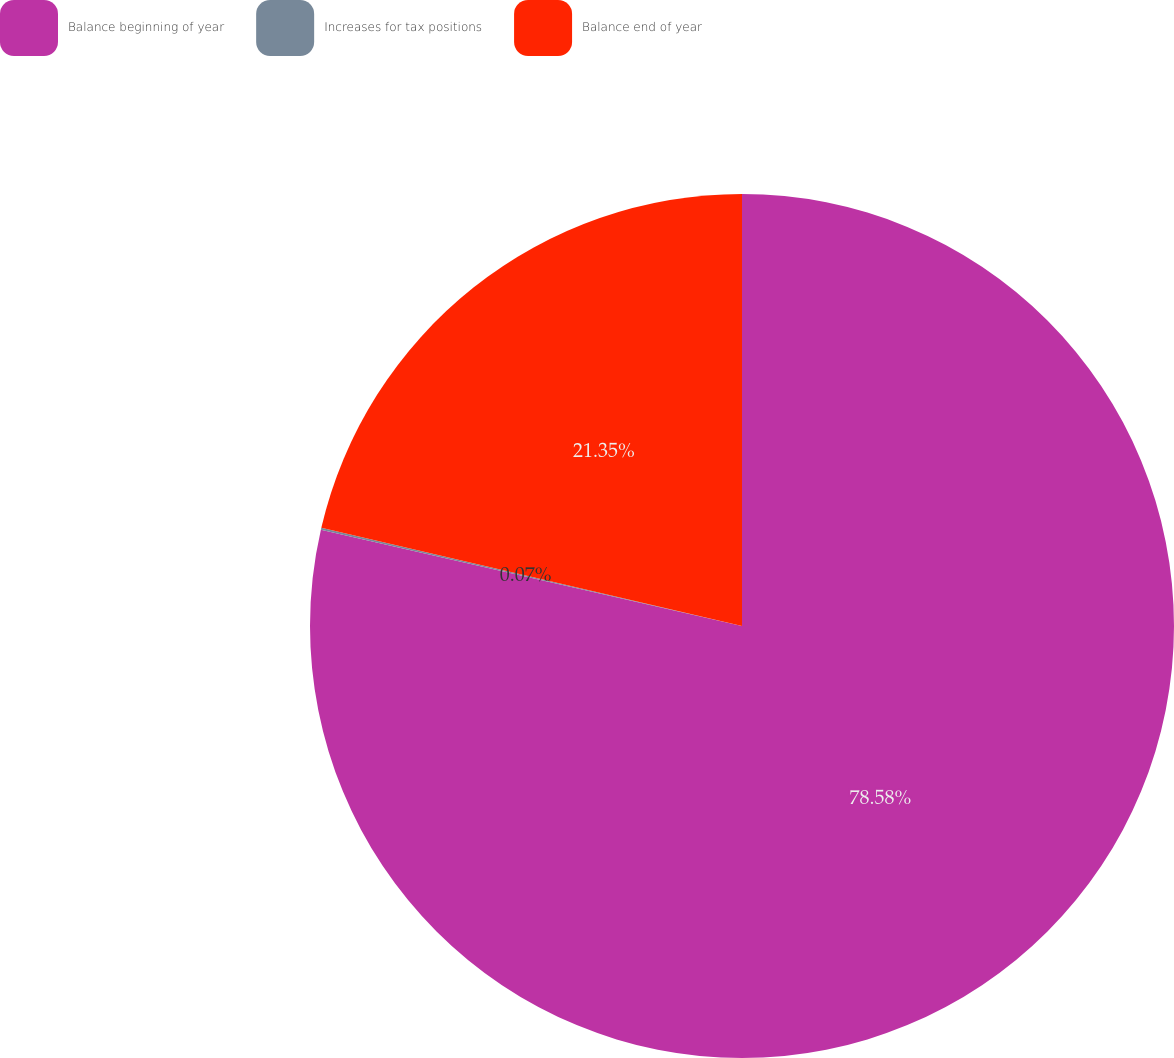Convert chart to OTSL. <chart><loc_0><loc_0><loc_500><loc_500><pie_chart><fcel>Balance beginning of year<fcel>Increases for tax positions<fcel>Balance end of year<nl><fcel>78.58%<fcel>0.07%<fcel>21.35%<nl></chart> 